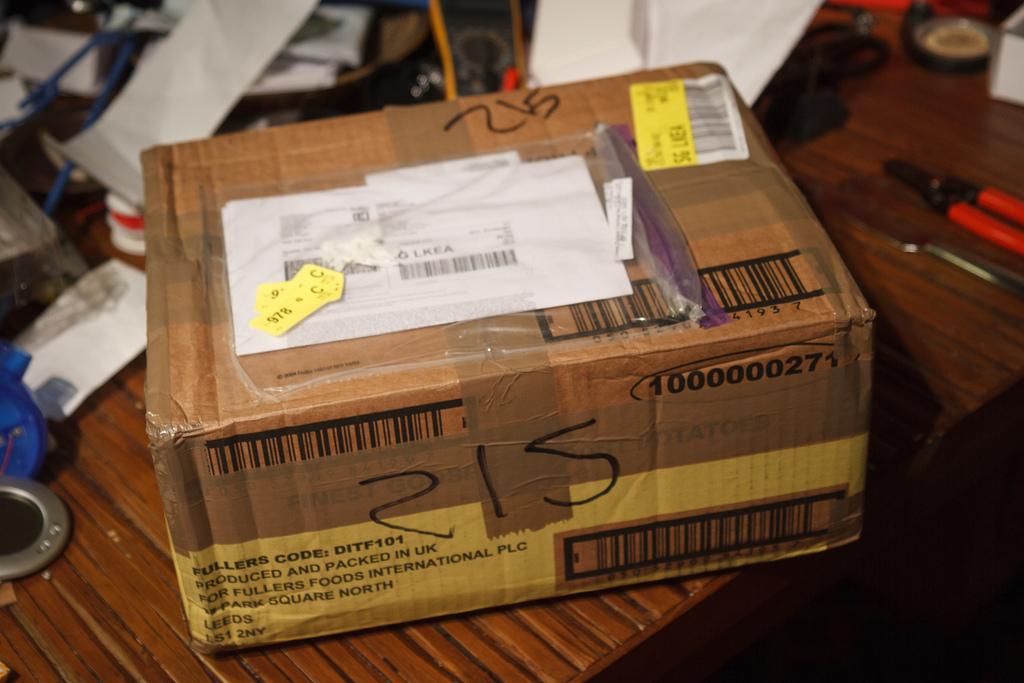What number is this box?
Ensure brevity in your answer.  215. 